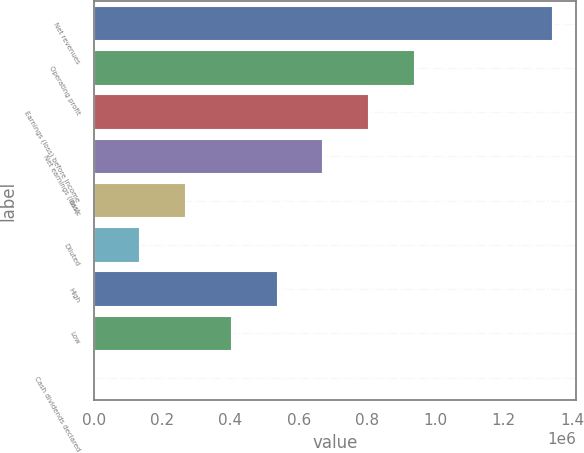<chart> <loc_0><loc_0><loc_500><loc_500><bar_chart><fcel>Net revenues<fcel>Operating profit<fcel>Earnings (loss) before income<fcel>Net earnings (loss)<fcel>Basic<fcel>Diluted<fcel>High<fcel>Low<fcel>Cash dividends declared<nl><fcel>1.34514e+06<fcel>941596<fcel>807082<fcel>672569<fcel>269028<fcel>134514<fcel>538055<fcel>403541<fcel>0.36<nl></chart> 